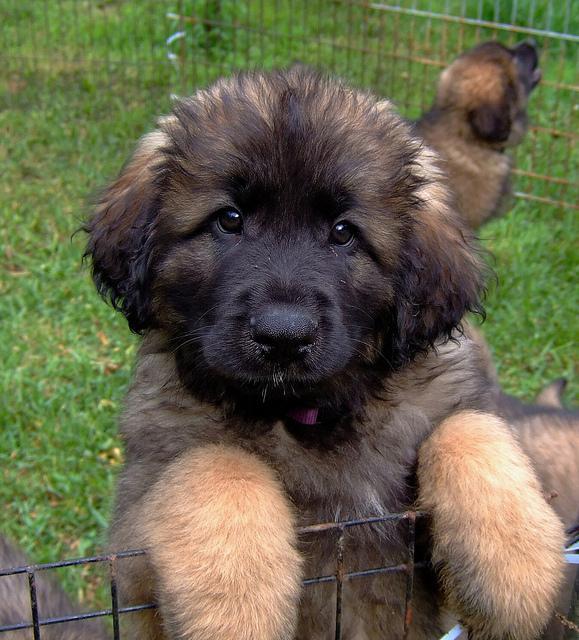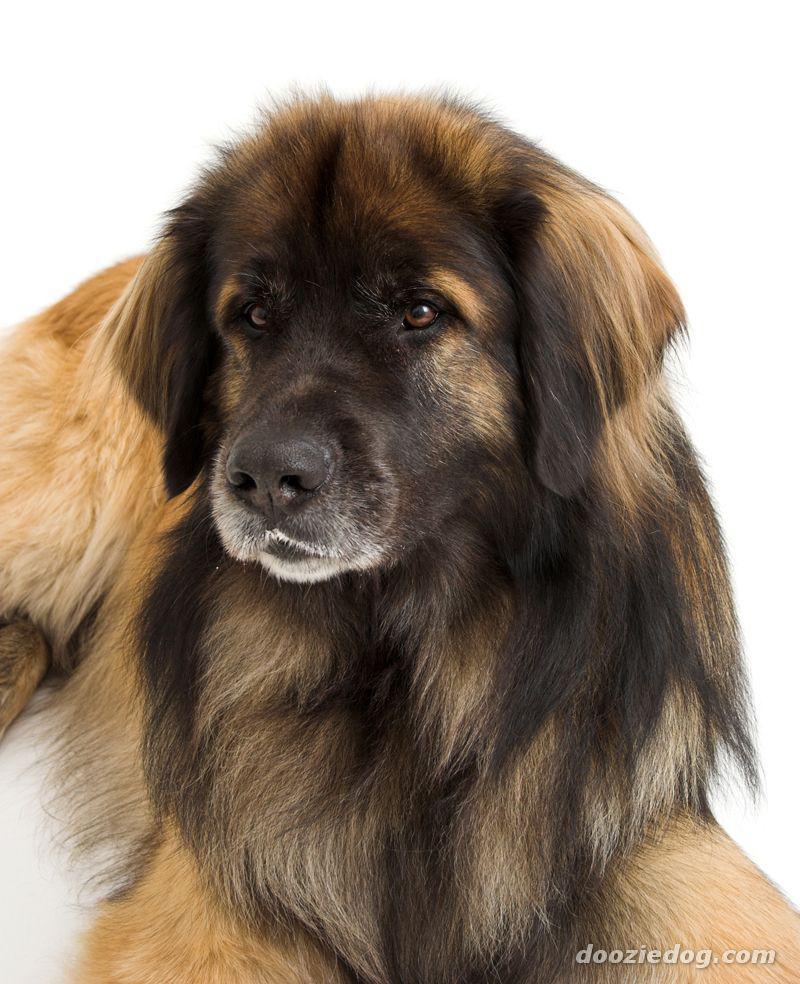The first image is the image on the left, the second image is the image on the right. For the images shown, is this caption "The dogs in the two images are looking in the same direction, and no dog has its tongue showing." true? Answer yes or no. No. The first image is the image on the left, the second image is the image on the right. For the images displayed, is the sentence "The dog in one of the images is lying down on the carpet." factually correct? Answer yes or no. No. 